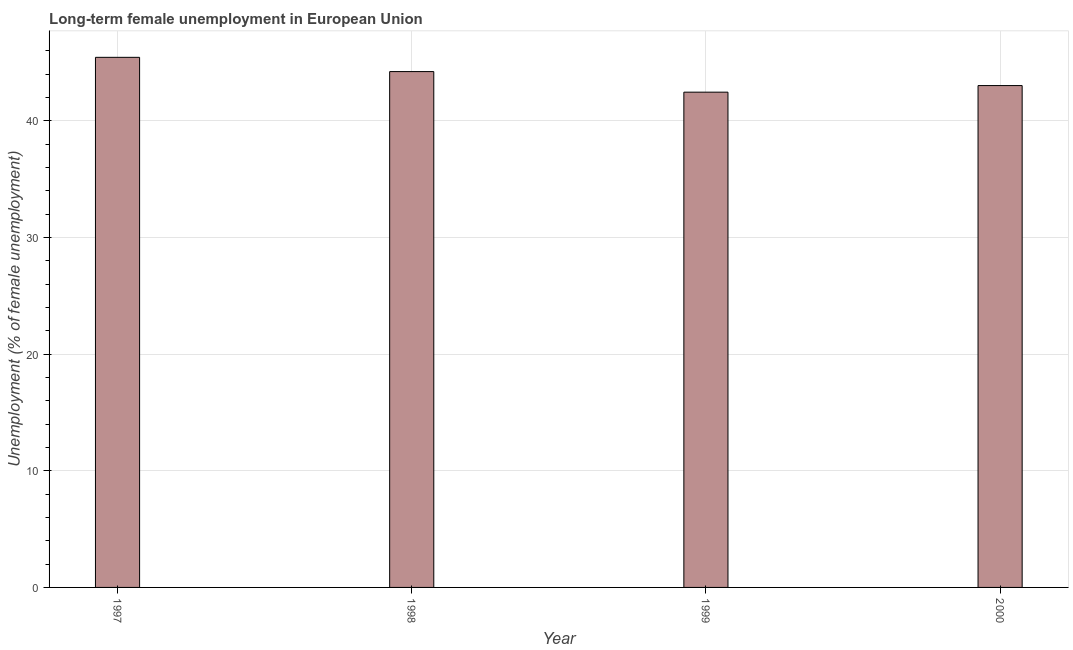Does the graph contain any zero values?
Keep it short and to the point. No. What is the title of the graph?
Ensure brevity in your answer.  Long-term female unemployment in European Union. What is the label or title of the X-axis?
Your response must be concise. Year. What is the label or title of the Y-axis?
Your answer should be very brief. Unemployment (% of female unemployment). What is the long-term female unemployment in 2000?
Provide a short and direct response. 43.02. Across all years, what is the maximum long-term female unemployment?
Your response must be concise. 45.45. Across all years, what is the minimum long-term female unemployment?
Ensure brevity in your answer.  42.46. In which year was the long-term female unemployment minimum?
Your response must be concise. 1999. What is the sum of the long-term female unemployment?
Ensure brevity in your answer.  175.15. What is the difference between the long-term female unemployment in 1997 and 1998?
Ensure brevity in your answer.  1.22. What is the average long-term female unemployment per year?
Provide a short and direct response. 43.79. What is the median long-term female unemployment?
Your answer should be compact. 43.62. In how many years, is the long-term female unemployment greater than 40 %?
Make the answer very short. 4. Do a majority of the years between 1998 and 2000 (inclusive) have long-term female unemployment greater than 34 %?
Your answer should be very brief. Yes. What is the ratio of the long-term female unemployment in 1998 to that in 2000?
Your response must be concise. 1.03. Is the difference between the long-term female unemployment in 1997 and 2000 greater than the difference between any two years?
Make the answer very short. No. What is the difference between the highest and the second highest long-term female unemployment?
Offer a very short reply. 1.22. What is the difference between the highest and the lowest long-term female unemployment?
Provide a short and direct response. 2.99. In how many years, is the long-term female unemployment greater than the average long-term female unemployment taken over all years?
Offer a very short reply. 2. How many bars are there?
Ensure brevity in your answer.  4. Are all the bars in the graph horizontal?
Your response must be concise. No. What is the difference between two consecutive major ticks on the Y-axis?
Provide a succinct answer. 10. What is the Unemployment (% of female unemployment) in 1997?
Keep it short and to the point. 45.45. What is the Unemployment (% of female unemployment) in 1998?
Provide a succinct answer. 44.22. What is the Unemployment (% of female unemployment) in 1999?
Your response must be concise. 42.46. What is the Unemployment (% of female unemployment) of 2000?
Provide a short and direct response. 43.02. What is the difference between the Unemployment (% of female unemployment) in 1997 and 1998?
Your answer should be very brief. 1.22. What is the difference between the Unemployment (% of female unemployment) in 1997 and 1999?
Your answer should be compact. 2.99. What is the difference between the Unemployment (% of female unemployment) in 1997 and 2000?
Offer a very short reply. 2.42. What is the difference between the Unemployment (% of female unemployment) in 1998 and 1999?
Provide a succinct answer. 1.76. What is the difference between the Unemployment (% of female unemployment) in 1998 and 2000?
Ensure brevity in your answer.  1.2. What is the difference between the Unemployment (% of female unemployment) in 1999 and 2000?
Provide a succinct answer. -0.56. What is the ratio of the Unemployment (% of female unemployment) in 1997 to that in 1998?
Make the answer very short. 1.03. What is the ratio of the Unemployment (% of female unemployment) in 1997 to that in 1999?
Your answer should be compact. 1.07. What is the ratio of the Unemployment (% of female unemployment) in 1997 to that in 2000?
Keep it short and to the point. 1.06. What is the ratio of the Unemployment (% of female unemployment) in 1998 to that in 1999?
Offer a terse response. 1.04. What is the ratio of the Unemployment (% of female unemployment) in 1998 to that in 2000?
Offer a terse response. 1.03. What is the ratio of the Unemployment (% of female unemployment) in 1999 to that in 2000?
Offer a very short reply. 0.99. 